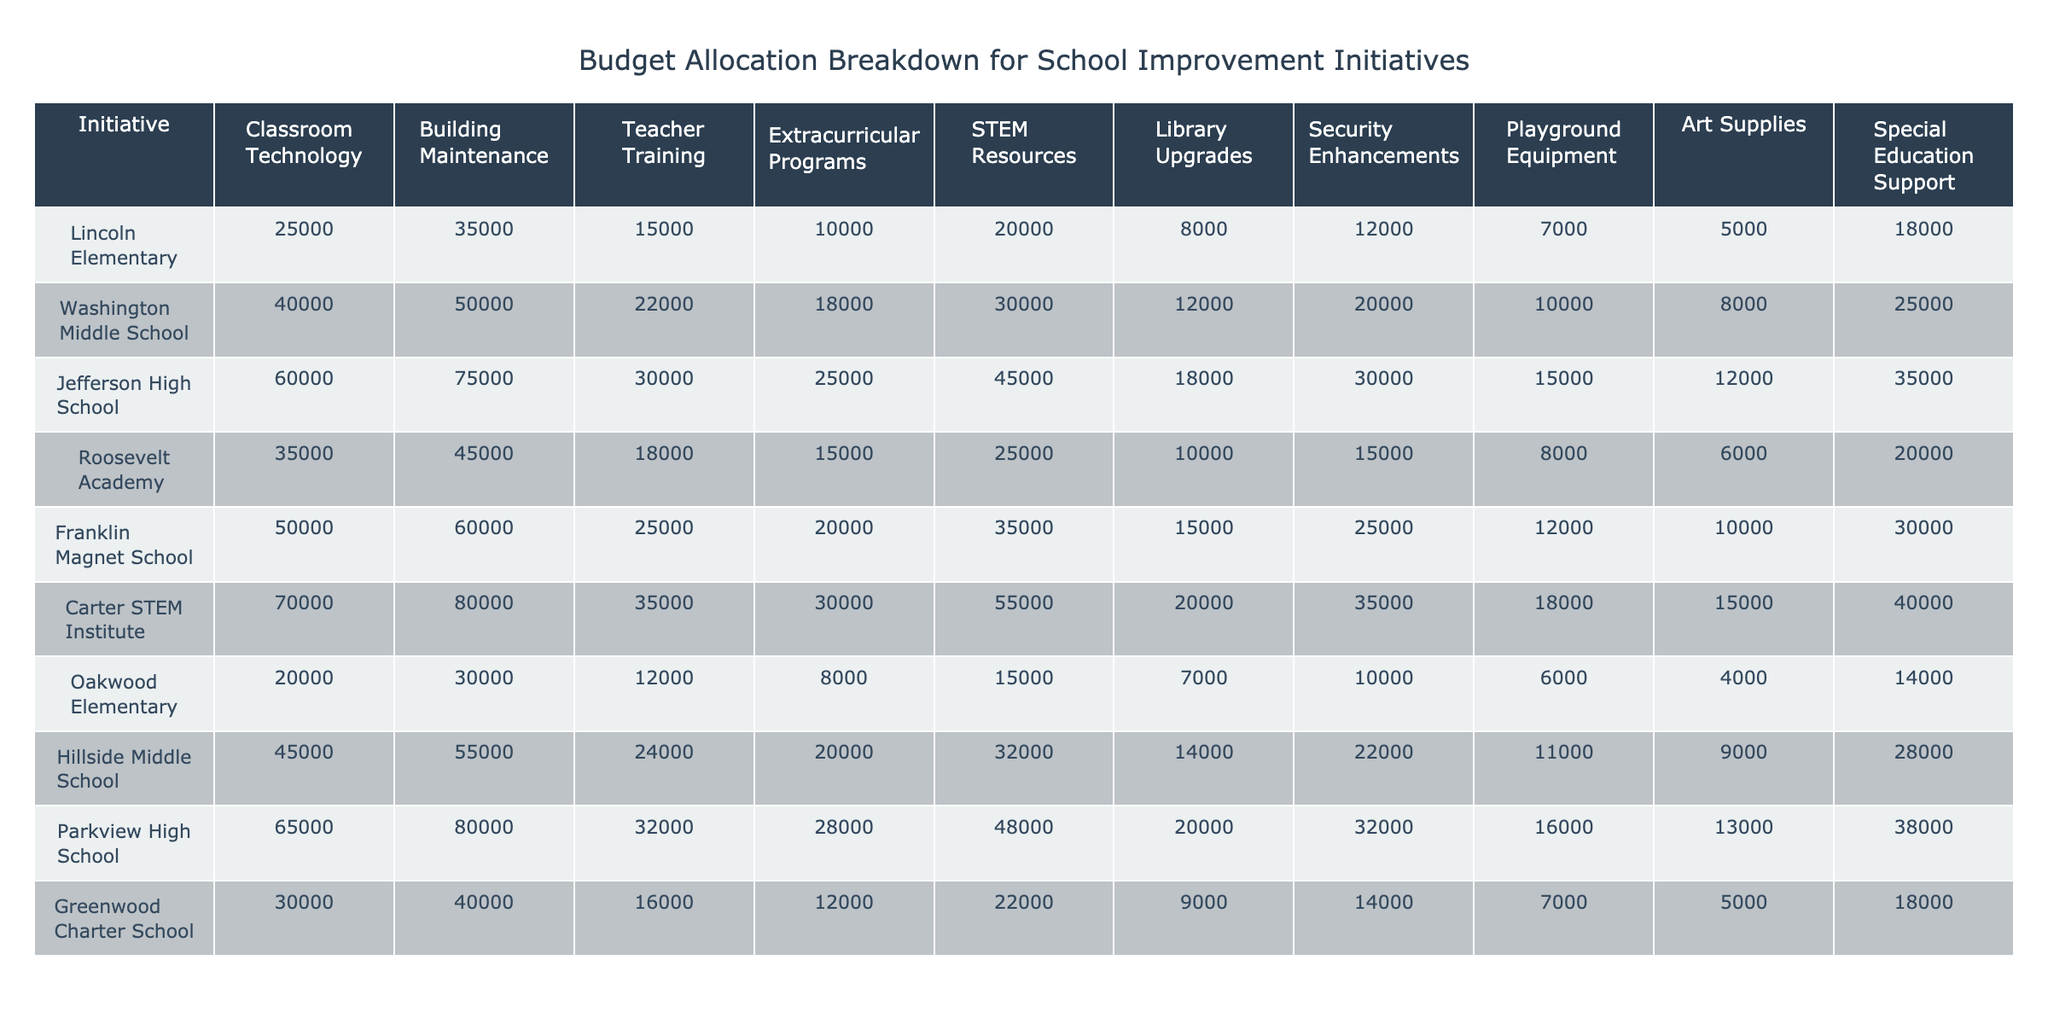What is the total budget allocated for teacher training across all schools? To find the total budget for teacher training, I will sum the values in the "Teacher Training" column: 15000 + 22000 + 30000 + 18000 + 25000 + 35000 + 12000 + 24000 + 32000 + 16000 = 197000.
Answer: 197000 Which school has the highest budget allocation for building maintenance? By reviewing the "Building Maintenance" column, I can identify the maximum value, which is 80000, and it corresponds to Carter STEM Institute.
Answer: Carter STEM Institute What percentage of the total budget for Lincoln Elementary is allocated to classroom technology? The total budget for Lincoln Elementary is 25000 + 35000 + 15000 + 10000 + 20000 + 8000 + 12000 + 7000 + 5000 + 18000 = 157000. The allocation for classroom technology is 25000. The percentage is (25000 / 157000) * 100 = 15.92%.
Answer: 15.92% Which initiative received the lowest funding in the entire table? I will look through each school's funding for the various initiatives. The lowest amount is 4000 in the "Playground Equipment" category for Oakwood Elementary.
Answer: Playground Equipment at Oakwood Elementary Is Jefferson High School allocating more money to security enhancements than to library upgrades? By examining the table, Jefferson High School has 30000 for security enhancements and 18000 for library upgrades. Since 30000 is greater than 18000, the statement is true.
Answer: Yes What is the average amount allocated to extracurricular programs across all schools? First, I sum the values in the "Extracurricular Programs" column: 10000 + 18000 + 25000 + 15000 + 20000 + 30000 + 8000 + 20000 + 28000 + 12000 = 124000. Then, I divide by the number of schools, which is 10. Therefore, the average is 124000 / 10 = 12400.
Answer: 12400 Which school has the second highest overall budget allocation? The total budgets for each school need to be calculated: Lincoln (157000), Washington (185000), Jefferson (360000), Roosevelt (161000), Franklin (230000), Carter (397000), Oakwood (85000), Hillside (170000), Parkview (360000), Greenwood (100000). The school with the second highest allocation is Parkview High School (360000), tied with Jefferson High.
Answer: Parkview High School Does any school allocate the same amount to security enhancements and special education support? By checking the table, I see the amounts for security enhancements and special education support for each school. Carter STEM Institute has 35000 for security enhancements and 40000 for special education support, which matches with no other school. Thus, no schools have the same allocation for both categories.
Answer: No What is the difference in funding for STEM resources between the school with the highest allocation and the school with the lowest allocation? The highest allocation for STEM resources is 55000 (Carter STEM Institute), and the lowest allocation is 15000 (Oakwood Elementary). Therefore, the difference is 55000 - 15000 = 40000.
Answer: 40000 Which two initiatives received the most total funding across all schools? First, I will sum the totals for each initiative across all schools: Classroom Technology = 25000 + 40000 + 60000 + 35000 + 50000 + 70000 + 20000 + 45000 + 65000 + 30000 = 300000; Building Maintenance = 35000 + 50000 + 75000 + 45000 + 60000 + 80000 + 30000 + 55000 + 80000 + 40000 = 462500. Thus, the two initiatives with the most funding are Building Maintenance and Classroom Technology.
Answer: Building Maintenance and Classroom Technology 